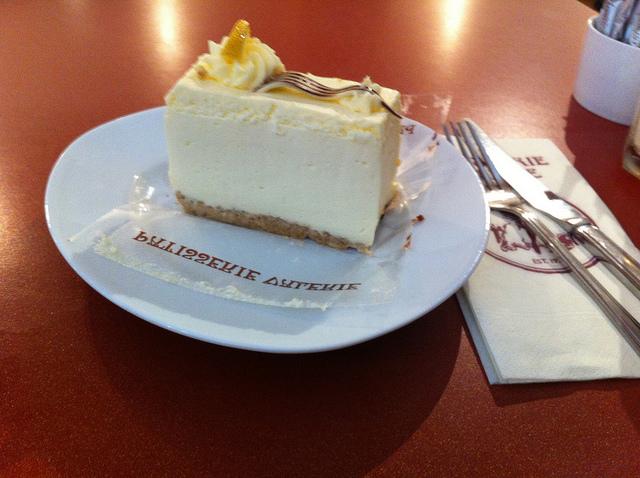Do you need fork and knife to eat this piece of cake?
Short answer required. No. What type of desert is pictured?
Write a very short answer. Cheesecake. Would this have a lot of calories?
Keep it brief. Yes. Is this cake supposed to serve several people?
Give a very brief answer. No. 